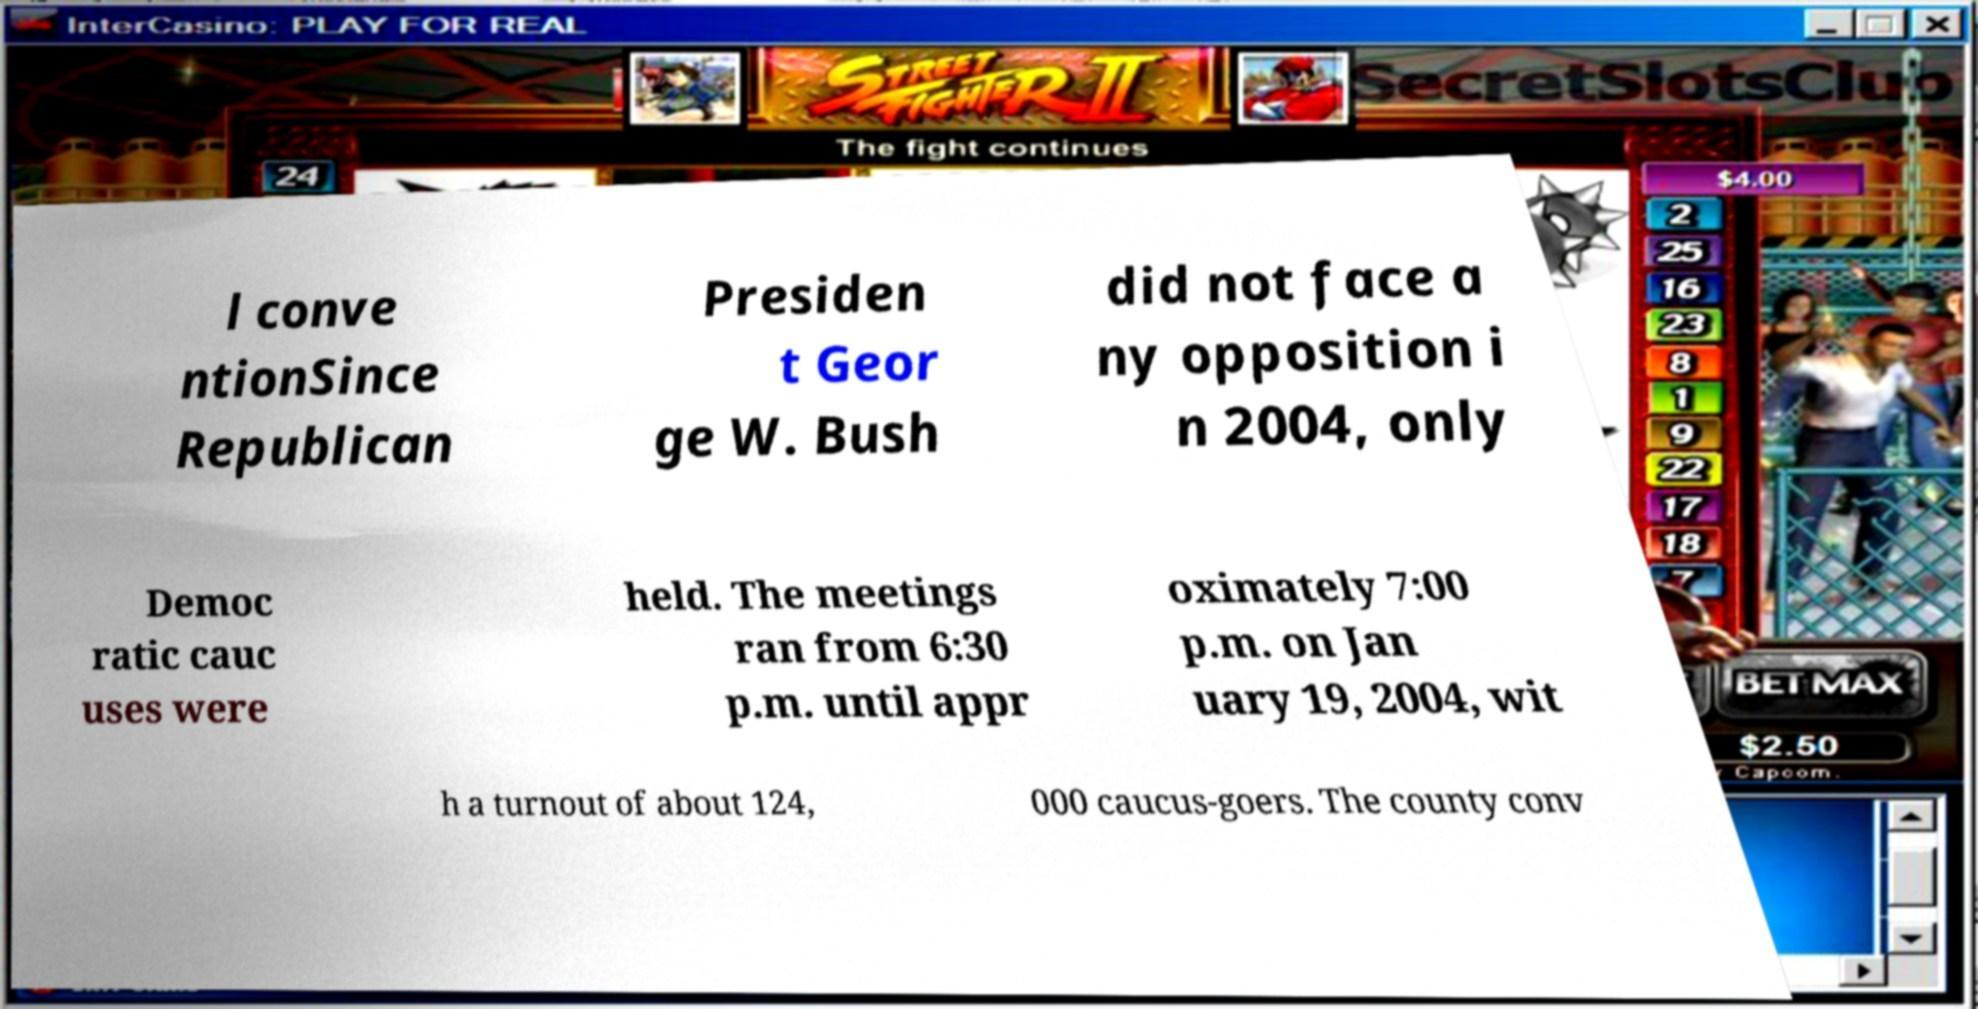For documentation purposes, I need the text within this image transcribed. Could you provide that? l conve ntionSince Republican Presiden t Geor ge W. Bush did not face a ny opposition i n 2004, only Democ ratic cauc uses were held. The meetings ran from 6:30 p.m. until appr oximately 7:00 p.m. on Jan uary 19, 2004, wit h a turnout of about 124, 000 caucus-goers. The county conv 